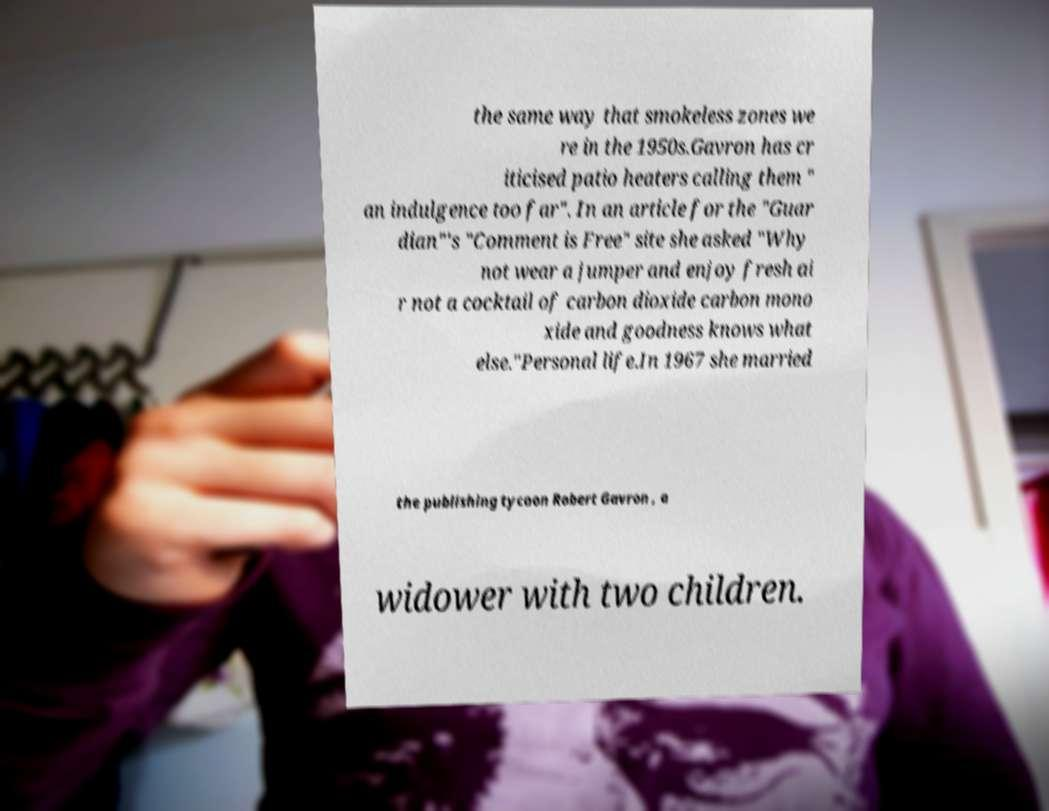Could you assist in decoding the text presented in this image and type it out clearly? the same way that smokeless zones we re in the 1950s.Gavron has cr iticised patio heaters calling them " an indulgence too far". In an article for the "Guar dian"'s "Comment is Free" site she asked "Why not wear a jumper and enjoy fresh ai r not a cocktail of carbon dioxide carbon mono xide and goodness knows what else."Personal life.In 1967 she married the publishing tycoon Robert Gavron , a widower with two children. 